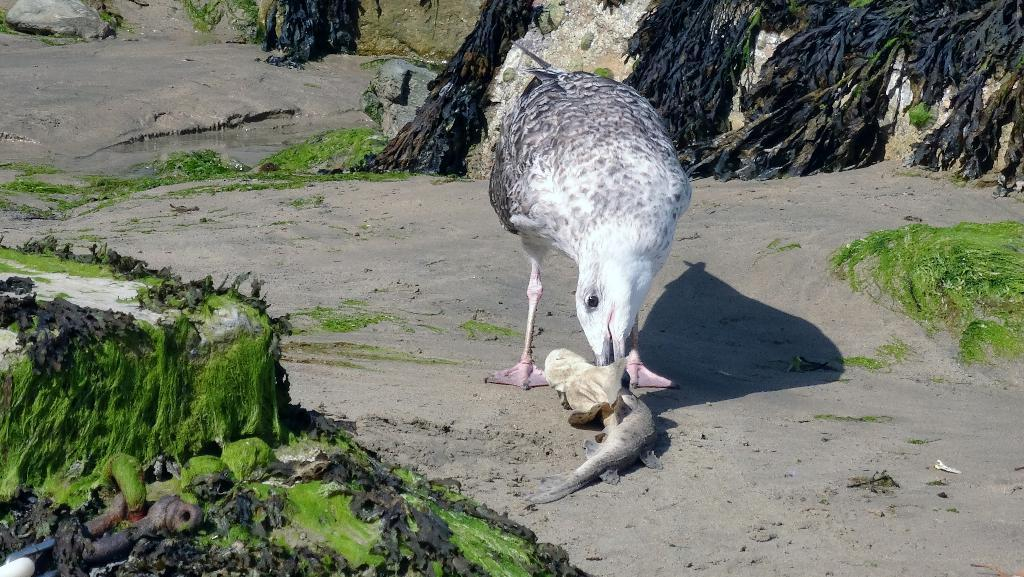What animal can be seen in the image? There is a bird in the image. What is the bird doing in the image? The bird is eating a fish. What type of environment is depicted in the background of the image? There are rocks, algae, mud, and water visible in the background of the image. What invention is the bird using to balance on the fish? The bird is not using any invention to balance on the fish; it is simply eating the fish. 